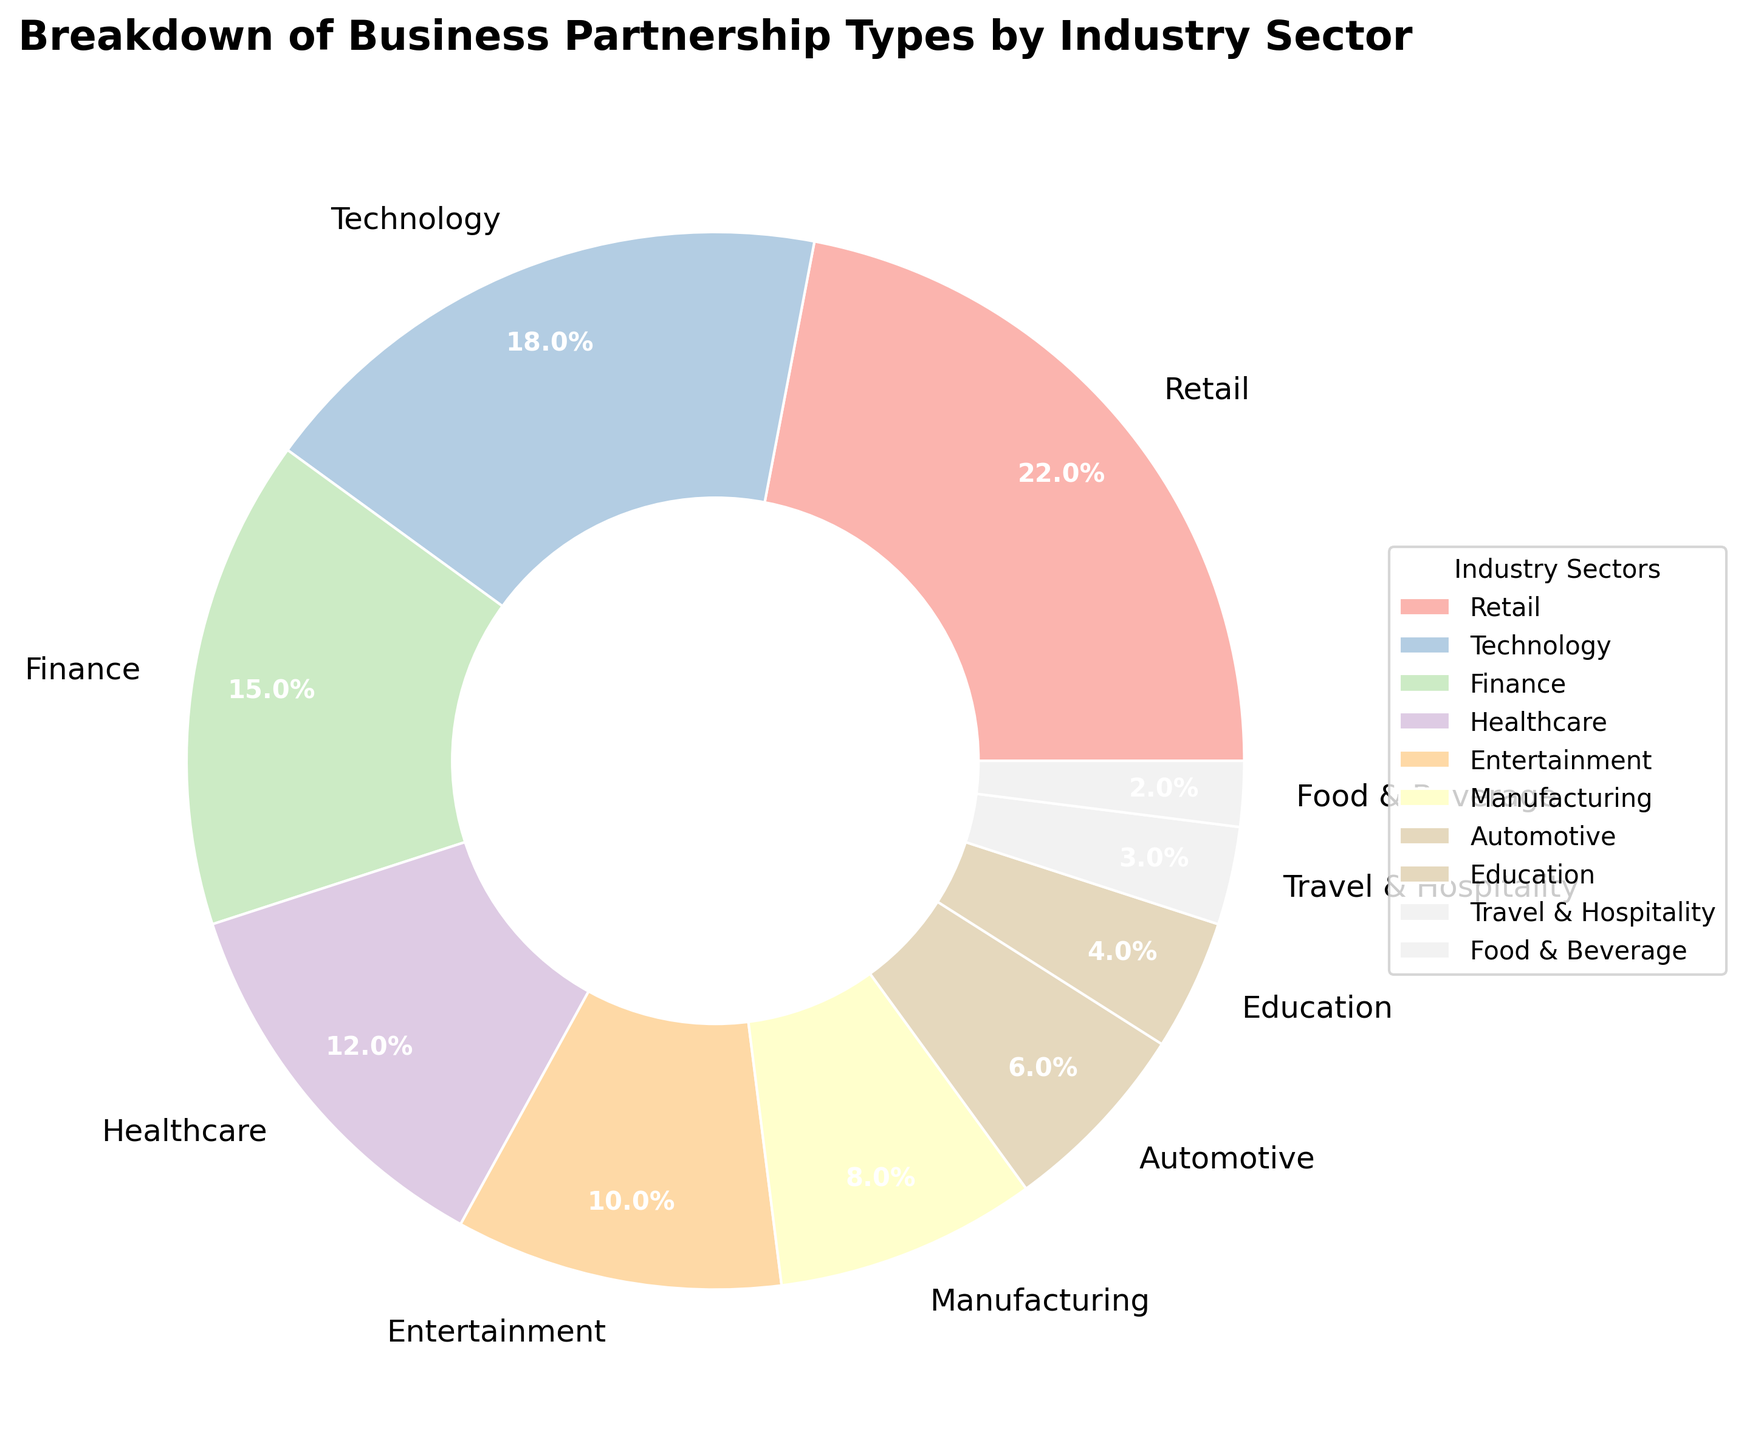Which industry sector has the largest percentage of business partnerships? The figure shows the distribution of business partnerships by industry sector in a pie chart. By looking at the slices, the "Retail" sector has the largest slice.
Answer: Retail What is the combined percentage of the Retail, Technology, and Finance sectors? The percentages for Retail, Technology, and Finance are 22%, 18%, and 15% respectively. Adding these together, 22% + 18% + 15% = 55%.
Answer: 55% Which industry sectors have percentages less than 5%? The sectors with slices representing less than 5% are "Education," "Travel & Hospitality," and "Food & Beverage" with 4%, 3%, and 2% respectively.
Answer: Education, Travel & Hospitality, Food & Beverage Is the Healthcare sector's share more than the shares of Automotive and Education combined? The Healthcare sector is 12%, Automotive is 6%, and Education is 4%. Adding Automotive and Education gives 6% + 4% = 10%, which is less than Healthcare's 12%.
Answer: Yes What is the percentage difference between the Retail and Healthcare sectors? The Retail sector is 22% and the Healthcare sector is 12%. The difference is 22% - 12% = 10%.
Answer: 10% How many sectors have a percentage of 10% or more? The sectors that meet this criterion are Retail (22%), Technology (18%), Finance (15%), Healthcare (12%), and Entertainment (10%). There are five sectors in total.
Answer: 5 Which sector has a smaller percentage, Manufacturing or Automotive? The Manufacturing sector's share is 8% and the Automotive sector's share is 6%. Therefore, Automotive has a smaller percentage.
Answer: Automotive By how much is the share of the Technology sector greater than that of the Food & Beverage sector? The share of the Technology sector is 18%, and the share of the Food & Beverage sector is 2%. The difference is 18% - 2% = 16%.
Answer: 16% What percentage of business partnerships are represented by sectors under 10%? The sectors under 10% are Manufacturing (8%), Automotive (6%), Education (4%), Travel & Hospitality (3%), and Food & Beverage (2%). Adding these gives 8% + 6% + 4% + 3% + 2% = 23%.
Answer: 23% 